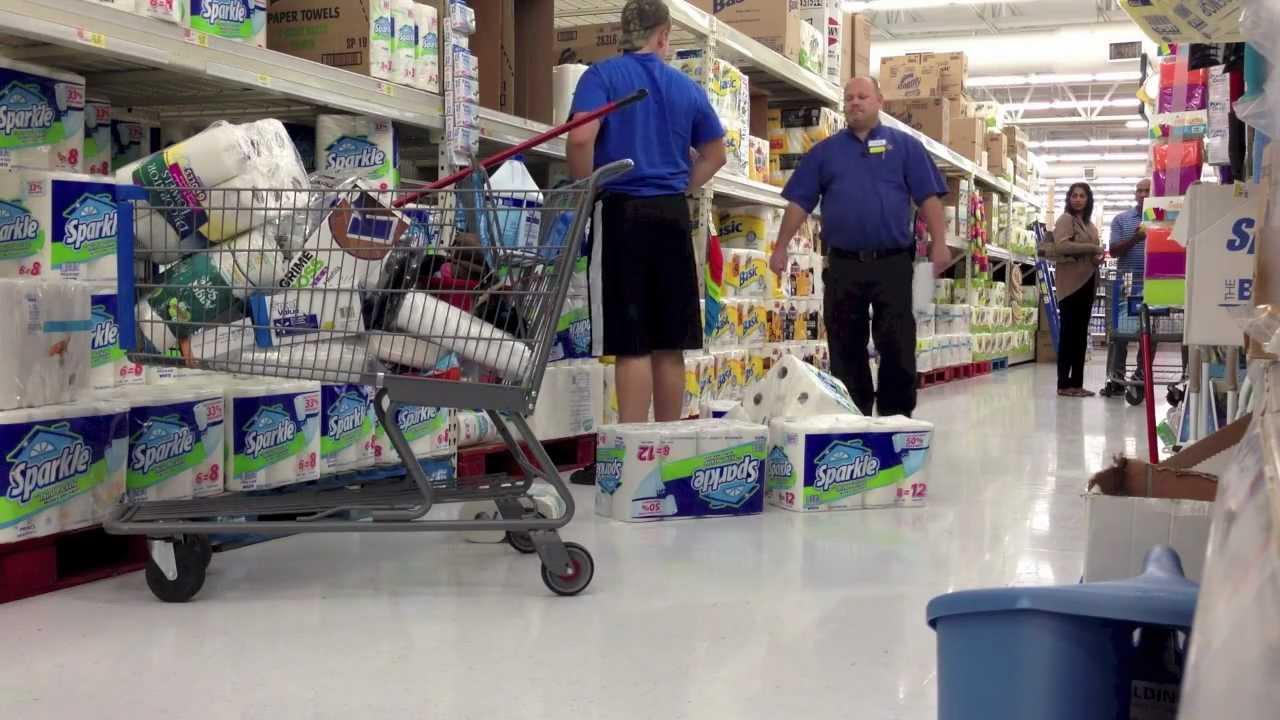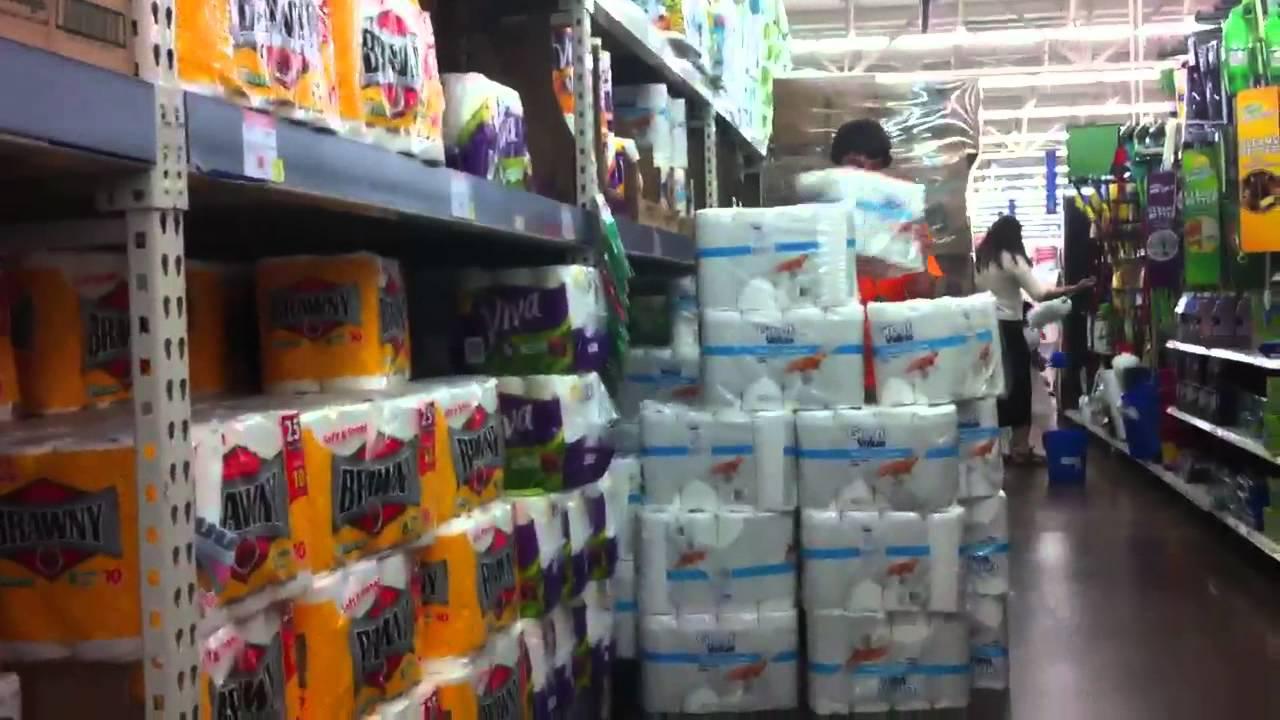The first image is the image on the left, the second image is the image on the right. Given the left and right images, does the statement "A single person sits nears piles of paper goods in the image on the right." hold true? Answer yes or no. No. 